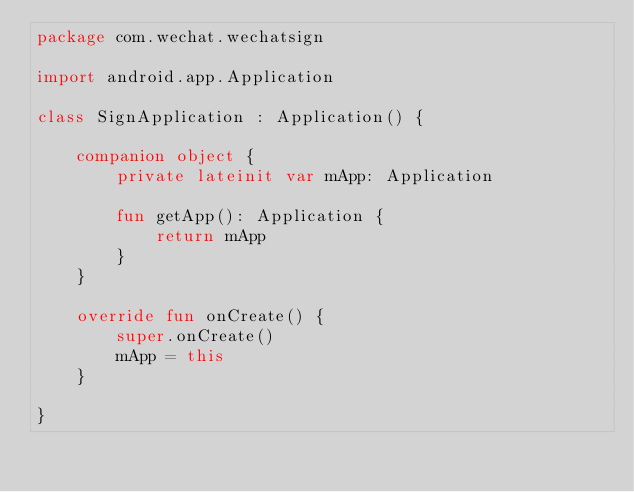<code> <loc_0><loc_0><loc_500><loc_500><_Kotlin_>package com.wechat.wechatsign

import android.app.Application

class SignApplication : Application() {

    companion object {
        private lateinit var mApp: Application

        fun getApp(): Application {
            return mApp
        }
    }

    override fun onCreate() {
        super.onCreate()
        mApp = this
    }

}</code> 